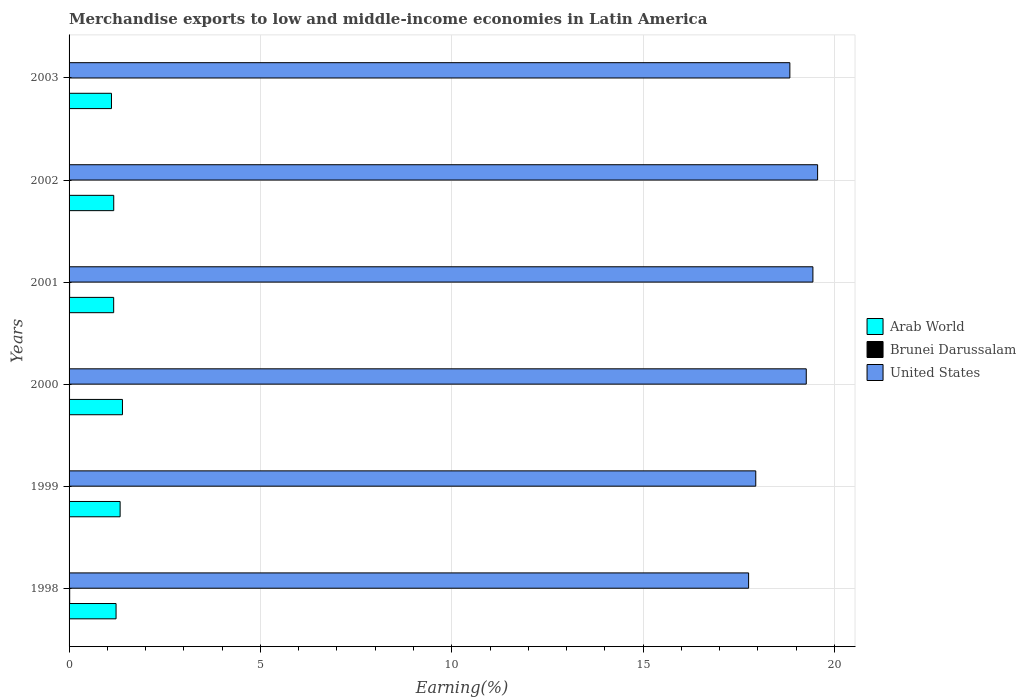How many different coloured bars are there?
Ensure brevity in your answer.  3. How many groups of bars are there?
Give a very brief answer. 6. How many bars are there on the 2nd tick from the bottom?
Make the answer very short. 3. In how many cases, is the number of bars for a given year not equal to the number of legend labels?
Your answer should be compact. 0. What is the percentage of amount earned from merchandise exports in Brunei Darussalam in 2002?
Your answer should be compact. 0. Across all years, what is the maximum percentage of amount earned from merchandise exports in Brunei Darussalam?
Offer a very short reply. 0.02. Across all years, what is the minimum percentage of amount earned from merchandise exports in United States?
Offer a very short reply. 17.76. What is the total percentage of amount earned from merchandise exports in Brunei Darussalam in the graph?
Give a very brief answer. 0.06. What is the difference between the percentage of amount earned from merchandise exports in Brunei Darussalam in 1998 and that in 2002?
Your answer should be very brief. 0.01. What is the difference between the percentage of amount earned from merchandise exports in Brunei Darussalam in 1999 and the percentage of amount earned from merchandise exports in United States in 2002?
Offer a terse response. -19.55. What is the average percentage of amount earned from merchandise exports in United States per year?
Ensure brevity in your answer.  18.8. In the year 2001, what is the difference between the percentage of amount earned from merchandise exports in Brunei Darussalam and percentage of amount earned from merchandise exports in Arab World?
Make the answer very short. -1.15. In how many years, is the percentage of amount earned from merchandise exports in United States greater than 13 %?
Provide a short and direct response. 6. What is the ratio of the percentage of amount earned from merchandise exports in United States in 2000 to that in 2002?
Offer a terse response. 0.98. What is the difference between the highest and the second highest percentage of amount earned from merchandise exports in United States?
Your response must be concise. 0.12. What is the difference between the highest and the lowest percentage of amount earned from merchandise exports in United States?
Give a very brief answer. 1.8. Is the sum of the percentage of amount earned from merchandise exports in Arab World in 1998 and 2003 greater than the maximum percentage of amount earned from merchandise exports in United States across all years?
Offer a terse response. No. What does the 2nd bar from the top in 2000 represents?
Make the answer very short. Brunei Darussalam. What does the 1st bar from the bottom in 1998 represents?
Give a very brief answer. Arab World. Is it the case that in every year, the sum of the percentage of amount earned from merchandise exports in Brunei Darussalam and percentage of amount earned from merchandise exports in United States is greater than the percentage of amount earned from merchandise exports in Arab World?
Your response must be concise. Yes. How many years are there in the graph?
Keep it short and to the point. 6. What is the difference between two consecutive major ticks on the X-axis?
Provide a short and direct response. 5. Are the values on the major ticks of X-axis written in scientific E-notation?
Give a very brief answer. No. Does the graph contain any zero values?
Give a very brief answer. No. How many legend labels are there?
Keep it short and to the point. 3. How are the legend labels stacked?
Ensure brevity in your answer.  Vertical. What is the title of the graph?
Ensure brevity in your answer.  Merchandise exports to low and middle-income economies in Latin America. What is the label or title of the X-axis?
Your response must be concise. Earning(%). What is the Earning(%) in Arab World in 1998?
Ensure brevity in your answer.  1.23. What is the Earning(%) in Brunei Darussalam in 1998?
Your response must be concise. 0.02. What is the Earning(%) in United States in 1998?
Provide a short and direct response. 17.76. What is the Earning(%) of Arab World in 1999?
Give a very brief answer. 1.33. What is the Earning(%) of Brunei Darussalam in 1999?
Provide a short and direct response. 0.01. What is the Earning(%) of United States in 1999?
Provide a short and direct response. 17.94. What is the Earning(%) in Arab World in 2000?
Your response must be concise. 1.39. What is the Earning(%) of Brunei Darussalam in 2000?
Provide a short and direct response. 0.01. What is the Earning(%) in United States in 2000?
Provide a succinct answer. 19.26. What is the Earning(%) in Arab World in 2001?
Your answer should be compact. 1.17. What is the Earning(%) in Brunei Darussalam in 2001?
Offer a terse response. 0.01. What is the Earning(%) of United States in 2001?
Provide a short and direct response. 19.44. What is the Earning(%) in Arab World in 2002?
Give a very brief answer. 1.17. What is the Earning(%) of Brunei Darussalam in 2002?
Your answer should be compact. 0. What is the Earning(%) of United States in 2002?
Offer a very short reply. 19.56. What is the Earning(%) in Arab World in 2003?
Your answer should be very brief. 1.11. What is the Earning(%) in Brunei Darussalam in 2003?
Give a very brief answer. 0. What is the Earning(%) in United States in 2003?
Provide a short and direct response. 18.84. Across all years, what is the maximum Earning(%) of Arab World?
Ensure brevity in your answer.  1.39. Across all years, what is the maximum Earning(%) of Brunei Darussalam?
Give a very brief answer. 0.02. Across all years, what is the maximum Earning(%) in United States?
Provide a succinct answer. 19.56. Across all years, what is the minimum Earning(%) of Arab World?
Offer a terse response. 1.11. Across all years, what is the minimum Earning(%) of Brunei Darussalam?
Offer a very short reply. 0. Across all years, what is the minimum Earning(%) in United States?
Make the answer very short. 17.76. What is the total Earning(%) in Arab World in the graph?
Your answer should be very brief. 7.4. What is the total Earning(%) in Brunei Darussalam in the graph?
Offer a terse response. 0.06. What is the total Earning(%) of United States in the graph?
Provide a short and direct response. 112.8. What is the difference between the Earning(%) of Arab World in 1998 and that in 1999?
Give a very brief answer. -0.11. What is the difference between the Earning(%) of Brunei Darussalam in 1998 and that in 1999?
Ensure brevity in your answer.  0.01. What is the difference between the Earning(%) in United States in 1998 and that in 1999?
Give a very brief answer. -0.19. What is the difference between the Earning(%) of Arab World in 1998 and that in 2000?
Your response must be concise. -0.17. What is the difference between the Earning(%) of Brunei Darussalam in 1998 and that in 2000?
Give a very brief answer. 0. What is the difference between the Earning(%) in United States in 1998 and that in 2000?
Give a very brief answer. -1.51. What is the difference between the Earning(%) in Arab World in 1998 and that in 2001?
Ensure brevity in your answer.  0.06. What is the difference between the Earning(%) in Brunei Darussalam in 1998 and that in 2001?
Your answer should be compact. 0. What is the difference between the Earning(%) in United States in 1998 and that in 2001?
Give a very brief answer. -1.68. What is the difference between the Earning(%) of Arab World in 1998 and that in 2002?
Your answer should be compact. 0.06. What is the difference between the Earning(%) in Brunei Darussalam in 1998 and that in 2002?
Your answer should be very brief. 0.01. What is the difference between the Earning(%) of United States in 1998 and that in 2002?
Your response must be concise. -1.8. What is the difference between the Earning(%) of Arab World in 1998 and that in 2003?
Your answer should be very brief. 0.12. What is the difference between the Earning(%) in Brunei Darussalam in 1998 and that in 2003?
Provide a short and direct response. 0.01. What is the difference between the Earning(%) of United States in 1998 and that in 2003?
Keep it short and to the point. -1.08. What is the difference between the Earning(%) of Arab World in 1999 and that in 2000?
Your answer should be very brief. -0.06. What is the difference between the Earning(%) of Brunei Darussalam in 1999 and that in 2000?
Provide a short and direct response. -0.01. What is the difference between the Earning(%) of United States in 1999 and that in 2000?
Keep it short and to the point. -1.32. What is the difference between the Earning(%) in Arab World in 1999 and that in 2001?
Give a very brief answer. 0.17. What is the difference between the Earning(%) of Brunei Darussalam in 1999 and that in 2001?
Your answer should be very brief. -0.01. What is the difference between the Earning(%) of United States in 1999 and that in 2001?
Your answer should be compact. -1.49. What is the difference between the Earning(%) of Arab World in 1999 and that in 2002?
Provide a short and direct response. 0.17. What is the difference between the Earning(%) of Brunei Darussalam in 1999 and that in 2002?
Make the answer very short. 0. What is the difference between the Earning(%) in United States in 1999 and that in 2002?
Provide a short and direct response. -1.62. What is the difference between the Earning(%) in Arab World in 1999 and that in 2003?
Make the answer very short. 0.23. What is the difference between the Earning(%) in Brunei Darussalam in 1999 and that in 2003?
Your answer should be very brief. 0. What is the difference between the Earning(%) of United States in 1999 and that in 2003?
Offer a terse response. -0.89. What is the difference between the Earning(%) in Arab World in 2000 and that in 2001?
Make the answer very short. 0.23. What is the difference between the Earning(%) in Brunei Darussalam in 2000 and that in 2001?
Your answer should be very brief. -0. What is the difference between the Earning(%) in United States in 2000 and that in 2001?
Ensure brevity in your answer.  -0.17. What is the difference between the Earning(%) in Arab World in 2000 and that in 2002?
Give a very brief answer. 0.23. What is the difference between the Earning(%) in Brunei Darussalam in 2000 and that in 2002?
Your answer should be compact. 0.01. What is the difference between the Earning(%) of United States in 2000 and that in 2002?
Your answer should be compact. -0.3. What is the difference between the Earning(%) of Arab World in 2000 and that in 2003?
Your answer should be very brief. 0.29. What is the difference between the Earning(%) of Brunei Darussalam in 2000 and that in 2003?
Your answer should be compact. 0.01. What is the difference between the Earning(%) of United States in 2000 and that in 2003?
Give a very brief answer. 0.43. What is the difference between the Earning(%) of Arab World in 2001 and that in 2002?
Offer a very short reply. -0. What is the difference between the Earning(%) of Brunei Darussalam in 2001 and that in 2002?
Your response must be concise. 0.01. What is the difference between the Earning(%) in United States in 2001 and that in 2002?
Keep it short and to the point. -0.12. What is the difference between the Earning(%) of Arab World in 2001 and that in 2003?
Your response must be concise. 0.06. What is the difference between the Earning(%) in Brunei Darussalam in 2001 and that in 2003?
Ensure brevity in your answer.  0.01. What is the difference between the Earning(%) of United States in 2001 and that in 2003?
Your response must be concise. 0.6. What is the difference between the Earning(%) of Arab World in 2002 and that in 2003?
Your answer should be compact. 0.06. What is the difference between the Earning(%) of Brunei Darussalam in 2002 and that in 2003?
Give a very brief answer. 0. What is the difference between the Earning(%) of United States in 2002 and that in 2003?
Offer a very short reply. 0.73. What is the difference between the Earning(%) of Arab World in 1998 and the Earning(%) of Brunei Darussalam in 1999?
Make the answer very short. 1.22. What is the difference between the Earning(%) of Arab World in 1998 and the Earning(%) of United States in 1999?
Offer a very short reply. -16.72. What is the difference between the Earning(%) in Brunei Darussalam in 1998 and the Earning(%) in United States in 1999?
Your response must be concise. -17.93. What is the difference between the Earning(%) in Arab World in 1998 and the Earning(%) in Brunei Darussalam in 2000?
Provide a succinct answer. 1.22. What is the difference between the Earning(%) of Arab World in 1998 and the Earning(%) of United States in 2000?
Make the answer very short. -18.04. What is the difference between the Earning(%) in Brunei Darussalam in 1998 and the Earning(%) in United States in 2000?
Give a very brief answer. -19.25. What is the difference between the Earning(%) of Arab World in 1998 and the Earning(%) of Brunei Darussalam in 2001?
Keep it short and to the point. 1.21. What is the difference between the Earning(%) of Arab World in 1998 and the Earning(%) of United States in 2001?
Ensure brevity in your answer.  -18.21. What is the difference between the Earning(%) of Brunei Darussalam in 1998 and the Earning(%) of United States in 2001?
Provide a short and direct response. -19.42. What is the difference between the Earning(%) of Arab World in 1998 and the Earning(%) of Brunei Darussalam in 2002?
Your response must be concise. 1.22. What is the difference between the Earning(%) in Arab World in 1998 and the Earning(%) in United States in 2002?
Your answer should be compact. -18.33. What is the difference between the Earning(%) of Brunei Darussalam in 1998 and the Earning(%) of United States in 2002?
Offer a terse response. -19.54. What is the difference between the Earning(%) in Arab World in 1998 and the Earning(%) in Brunei Darussalam in 2003?
Offer a very short reply. 1.22. What is the difference between the Earning(%) in Arab World in 1998 and the Earning(%) in United States in 2003?
Give a very brief answer. -17.61. What is the difference between the Earning(%) in Brunei Darussalam in 1998 and the Earning(%) in United States in 2003?
Your answer should be compact. -18.82. What is the difference between the Earning(%) of Arab World in 1999 and the Earning(%) of Brunei Darussalam in 2000?
Keep it short and to the point. 1.32. What is the difference between the Earning(%) in Arab World in 1999 and the Earning(%) in United States in 2000?
Give a very brief answer. -17.93. What is the difference between the Earning(%) of Brunei Darussalam in 1999 and the Earning(%) of United States in 2000?
Offer a terse response. -19.26. What is the difference between the Earning(%) of Arab World in 1999 and the Earning(%) of Brunei Darussalam in 2001?
Provide a short and direct response. 1.32. What is the difference between the Earning(%) of Arab World in 1999 and the Earning(%) of United States in 2001?
Your response must be concise. -18.1. What is the difference between the Earning(%) in Brunei Darussalam in 1999 and the Earning(%) in United States in 2001?
Offer a very short reply. -19.43. What is the difference between the Earning(%) in Arab World in 1999 and the Earning(%) in Brunei Darussalam in 2002?
Provide a short and direct response. 1.33. What is the difference between the Earning(%) in Arab World in 1999 and the Earning(%) in United States in 2002?
Give a very brief answer. -18.23. What is the difference between the Earning(%) of Brunei Darussalam in 1999 and the Earning(%) of United States in 2002?
Your answer should be very brief. -19.55. What is the difference between the Earning(%) in Arab World in 1999 and the Earning(%) in Brunei Darussalam in 2003?
Your response must be concise. 1.33. What is the difference between the Earning(%) in Arab World in 1999 and the Earning(%) in United States in 2003?
Ensure brevity in your answer.  -17.5. What is the difference between the Earning(%) in Brunei Darussalam in 1999 and the Earning(%) in United States in 2003?
Offer a very short reply. -18.83. What is the difference between the Earning(%) of Arab World in 2000 and the Earning(%) of Brunei Darussalam in 2001?
Make the answer very short. 1.38. What is the difference between the Earning(%) of Arab World in 2000 and the Earning(%) of United States in 2001?
Provide a succinct answer. -18.04. What is the difference between the Earning(%) in Brunei Darussalam in 2000 and the Earning(%) in United States in 2001?
Your response must be concise. -19.43. What is the difference between the Earning(%) in Arab World in 2000 and the Earning(%) in Brunei Darussalam in 2002?
Keep it short and to the point. 1.39. What is the difference between the Earning(%) in Arab World in 2000 and the Earning(%) in United States in 2002?
Keep it short and to the point. -18.17. What is the difference between the Earning(%) of Brunei Darussalam in 2000 and the Earning(%) of United States in 2002?
Your answer should be compact. -19.55. What is the difference between the Earning(%) of Arab World in 2000 and the Earning(%) of Brunei Darussalam in 2003?
Your response must be concise. 1.39. What is the difference between the Earning(%) of Arab World in 2000 and the Earning(%) of United States in 2003?
Offer a terse response. -17.44. What is the difference between the Earning(%) in Brunei Darussalam in 2000 and the Earning(%) in United States in 2003?
Your answer should be compact. -18.82. What is the difference between the Earning(%) in Arab World in 2001 and the Earning(%) in Brunei Darussalam in 2002?
Give a very brief answer. 1.16. What is the difference between the Earning(%) in Arab World in 2001 and the Earning(%) in United States in 2002?
Provide a short and direct response. -18.39. What is the difference between the Earning(%) of Brunei Darussalam in 2001 and the Earning(%) of United States in 2002?
Provide a succinct answer. -19.55. What is the difference between the Earning(%) in Arab World in 2001 and the Earning(%) in Brunei Darussalam in 2003?
Make the answer very short. 1.16. What is the difference between the Earning(%) of Arab World in 2001 and the Earning(%) of United States in 2003?
Ensure brevity in your answer.  -17.67. What is the difference between the Earning(%) of Brunei Darussalam in 2001 and the Earning(%) of United States in 2003?
Your response must be concise. -18.82. What is the difference between the Earning(%) of Arab World in 2002 and the Earning(%) of Brunei Darussalam in 2003?
Ensure brevity in your answer.  1.16. What is the difference between the Earning(%) in Arab World in 2002 and the Earning(%) in United States in 2003?
Offer a terse response. -17.67. What is the difference between the Earning(%) in Brunei Darussalam in 2002 and the Earning(%) in United States in 2003?
Your response must be concise. -18.83. What is the average Earning(%) of Arab World per year?
Provide a short and direct response. 1.23. What is the average Earning(%) in Brunei Darussalam per year?
Ensure brevity in your answer.  0.01. What is the average Earning(%) of United States per year?
Provide a succinct answer. 18.8. In the year 1998, what is the difference between the Earning(%) of Arab World and Earning(%) of Brunei Darussalam?
Provide a succinct answer. 1.21. In the year 1998, what is the difference between the Earning(%) in Arab World and Earning(%) in United States?
Ensure brevity in your answer.  -16.53. In the year 1998, what is the difference between the Earning(%) in Brunei Darussalam and Earning(%) in United States?
Provide a succinct answer. -17.74. In the year 1999, what is the difference between the Earning(%) in Arab World and Earning(%) in Brunei Darussalam?
Keep it short and to the point. 1.33. In the year 1999, what is the difference between the Earning(%) of Arab World and Earning(%) of United States?
Make the answer very short. -16.61. In the year 1999, what is the difference between the Earning(%) of Brunei Darussalam and Earning(%) of United States?
Provide a short and direct response. -17.94. In the year 2000, what is the difference between the Earning(%) of Arab World and Earning(%) of Brunei Darussalam?
Ensure brevity in your answer.  1.38. In the year 2000, what is the difference between the Earning(%) of Arab World and Earning(%) of United States?
Keep it short and to the point. -17.87. In the year 2000, what is the difference between the Earning(%) of Brunei Darussalam and Earning(%) of United States?
Offer a very short reply. -19.25. In the year 2001, what is the difference between the Earning(%) in Arab World and Earning(%) in Brunei Darussalam?
Your response must be concise. 1.15. In the year 2001, what is the difference between the Earning(%) of Arab World and Earning(%) of United States?
Provide a short and direct response. -18.27. In the year 2001, what is the difference between the Earning(%) of Brunei Darussalam and Earning(%) of United States?
Your answer should be very brief. -19.42. In the year 2002, what is the difference between the Earning(%) in Arab World and Earning(%) in Brunei Darussalam?
Keep it short and to the point. 1.16. In the year 2002, what is the difference between the Earning(%) of Arab World and Earning(%) of United States?
Your answer should be compact. -18.39. In the year 2002, what is the difference between the Earning(%) of Brunei Darussalam and Earning(%) of United States?
Offer a terse response. -19.56. In the year 2003, what is the difference between the Earning(%) of Arab World and Earning(%) of Brunei Darussalam?
Offer a terse response. 1.1. In the year 2003, what is the difference between the Earning(%) in Arab World and Earning(%) in United States?
Provide a succinct answer. -17.73. In the year 2003, what is the difference between the Earning(%) in Brunei Darussalam and Earning(%) in United States?
Your answer should be very brief. -18.83. What is the ratio of the Earning(%) in Arab World in 1998 to that in 1999?
Provide a short and direct response. 0.92. What is the ratio of the Earning(%) in Brunei Darussalam in 1998 to that in 1999?
Provide a short and direct response. 3. What is the ratio of the Earning(%) in Arab World in 1998 to that in 2000?
Your answer should be compact. 0.88. What is the ratio of the Earning(%) in Brunei Darussalam in 1998 to that in 2000?
Give a very brief answer. 1.36. What is the ratio of the Earning(%) in United States in 1998 to that in 2000?
Provide a succinct answer. 0.92. What is the ratio of the Earning(%) in Arab World in 1998 to that in 2001?
Provide a short and direct response. 1.05. What is the ratio of the Earning(%) of Brunei Darussalam in 1998 to that in 2001?
Provide a short and direct response. 1.13. What is the ratio of the Earning(%) of United States in 1998 to that in 2001?
Keep it short and to the point. 0.91. What is the ratio of the Earning(%) in Arab World in 1998 to that in 2002?
Make the answer very short. 1.05. What is the ratio of the Earning(%) of Brunei Darussalam in 1998 to that in 2002?
Offer a terse response. 3.34. What is the ratio of the Earning(%) of United States in 1998 to that in 2002?
Keep it short and to the point. 0.91. What is the ratio of the Earning(%) of Arab World in 1998 to that in 2003?
Give a very brief answer. 1.11. What is the ratio of the Earning(%) in Brunei Darussalam in 1998 to that in 2003?
Ensure brevity in your answer.  3.86. What is the ratio of the Earning(%) in United States in 1998 to that in 2003?
Your answer should be very brief. 0.94. What is the ratio of the Earning(%) of Arab World in 1999 to that in 2000?
Offer a terse response. 0.96. What is the ratio of the Earning(%) of Brunei Darussalam in 1999 to that in 2000?
Offer a terse response. 0.45. What is the ratio of the Earning(%) of United States in 1999 to that in 2000?
Your response must be concise. 0.93. What is the ratio of the Earning(%) of Arab World in 1999 to that in 2001?
Your answer should be very brief. 1.14. What is the ratio of the Earning(%) in Brunei Darussalam in 1999 to that in 2001?
Provide a short and direct response. 0.38. What is the ratio of the Earning(%) in United States in 1999 to that in 2001?
Offer a very short reply. 0.92. What is the ratio of the Earning(%) of Arab World in 1999 to that in 2002?
Provide a succinct answer. 1.14. What is the ratio of the Earning(%) of Brunei Darussalam in 1999 to that in 2002?
Your answer should be compact. 1.11. What is the ratio of the Earning(%) in United States in 1999 to that in 2002?
Give a very brief answer. 0.92. What is the ratio of the Earning(%) of Arab World in 1999 to that in 2003?
Give a very brief answer. 1.2. What is the ratio of the Earning(%) of Brunei Darussalam in 1999 to that in 2003?
Provide a succinct answer. 1.29. What is the ratio of the Earning(%) in United States in 1999 to that in 2003?
Offer a very short reply. 0.95. What is the ratio of the Earning(%) in Arab World in 2000 to that in 2001?
Your response must be concise. 1.2. What is the ratio of the Earning(%) in Brunei Darussalam in 2000 to that in 2001?
Your answer should be very brief. 0.83. What is the ratio of the Earning(%) of Arab World in 2000 to that in 2002?
Your response must be concise. 1.2. What is the ratio of the Earning(%) in Brunei Darussalam in 2000 to that in 2002?
Provide a short and direct response. 2.46. What is the ratio of the Earning(%) of United States in 2000 to that in 2002?
Your answer should be compact. 0.98. What is the ratio of the Earning(%) in Arab World in 2000 to that in 2003?
Provide a succinct answer. 1.26. What is the ratio of the Earning(%) of Brunei Darussalam in 2000 to that in 2003?
Give a very brief answer. 2.84. What is the ratio of the Earning(%) in United States in 2000 to that in 2003?
Provide a succinct answer. 1.02. What is the ratio of the Earning(%) of Arab World in 2001 to that in 2002?
Ensure brevity in your answer.  1. What is the ratio of the Earning(%) in Brunei Darussalam in 2001 to that in 2002?
Offer a terse response. 2.97. What is the ratio of the Earning(%) in United States in 2001 to that in 2002?
Your answer should be very brief. 0.99. What is the ratio of the Earning(%) in Arab World in 2001 to that in 2003?
Give a very brief answer. 1.05. What is the ratio of the Earning(%) of Brunei Darussalam in 2001 to that in 2003?
Offer a terse response. 3.43. What is the ratio of the Earning(%) in United States in 2001 to that in 2003?
Ensure brevity in your answer.  1.03. What is the ratio of the Earning(%) in Arab World in 2002 to that in 2003?
Make the answer very short. 1.05. What is the ratio of the Earning(%) of Brunei Darussalam in 2002 to that in 2003?
Make the answer very short. 1.16. What is the ratio of the Earning(%) in United States in 2002 to that in 2003?
Ensure brevity in your answer.  1.04. What is the difference between the highest and the second highest Earning(%) in Arab World?
Provide a short and direct response. 0.06. What is the difference between the highest and the second highest Earning(%) of Brunei Darussalam?
Offer a very short reply. 0. What is the difference between the highest and the second highest Earning(%) of United States?
Your answer should be compact. 0.12. What is the difference between the highest and the lowest Earning(%) in Arab World?
Offer a very short reply. 0.29. What is the difference between the highest and the lowest Earning(%) in Brunei Darussalam?
Offer a terse response. 0.01. What is the difference between the highest and the lowest Earning(%) in United States?
Provide a succinct answer. 1.8. 